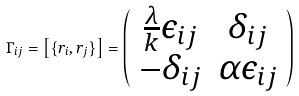Convert formula to latex. <formula><loc_0><loc_0><loc_500><loc_500>\Gamma _ { i j } = \left [ \{ r _ { i } , r _ { j } \} \right ] = \left ( \begin{array} { c c } { { \frac { \lambda } { k } \epsilon _ { i j } } } & { { \delta _ { i j } } } \\ { { - \delta _ { i j } } } & { { \alpha \epsilon _ { i j } } } \end{array} \right )</formula> 